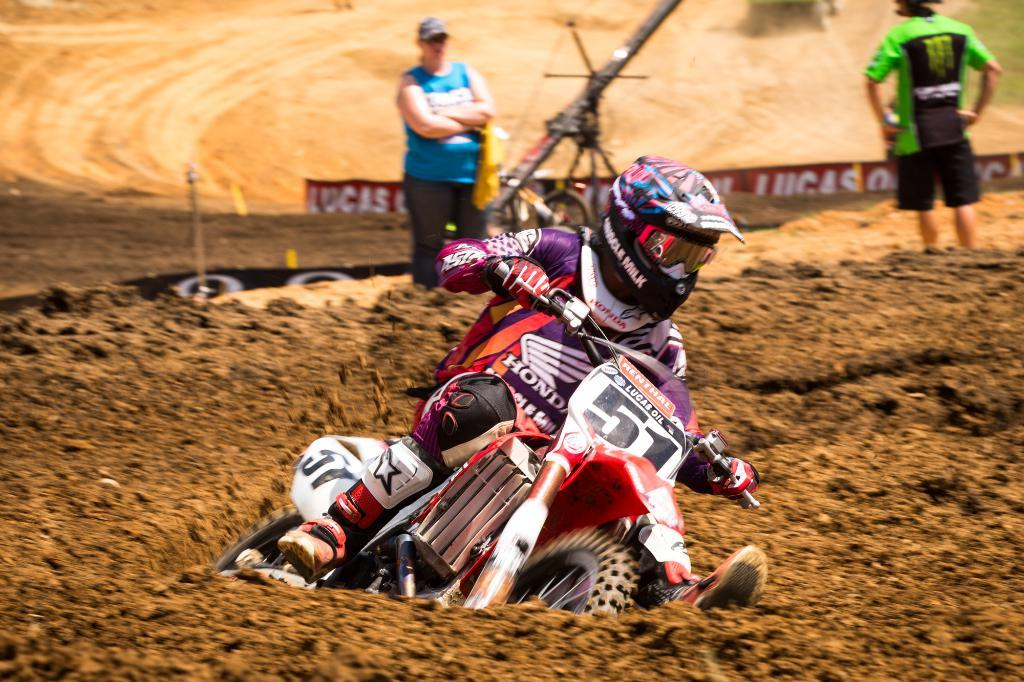What is the man in the image doing? The man is on a bike in the image. What safety precaution is the man taking? The man is wearing a helmet. How many people are standing in the image? There are two people standing in the image. What can be seen on the background or side of the image? There is a hoarding in the image. Is the grass on fire in the image? There is no grass present in the image, so it cannot be determined if it is on fire or not. 